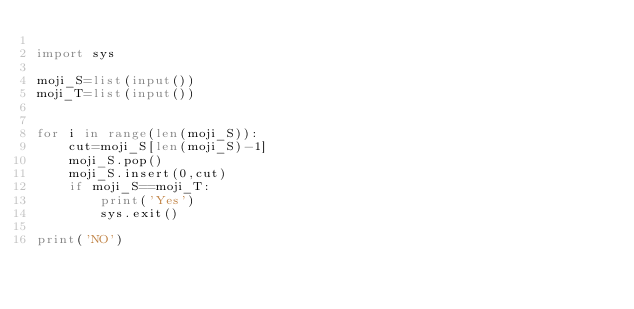<code> <loc_0><loc_0><loc_500><loc_500><_Python_>
import sys

moji_S=list(input())
moji_T=list(input())


for i in range(len(moji_S)):
	cut=moji_S[len(moji_S)-1]
	moji_S.pop()
	moji_S.insert(0,cut)
	if moji_S==moji_T:
		print('Yes')
		sys.exit()

print('NO')		
</code> 